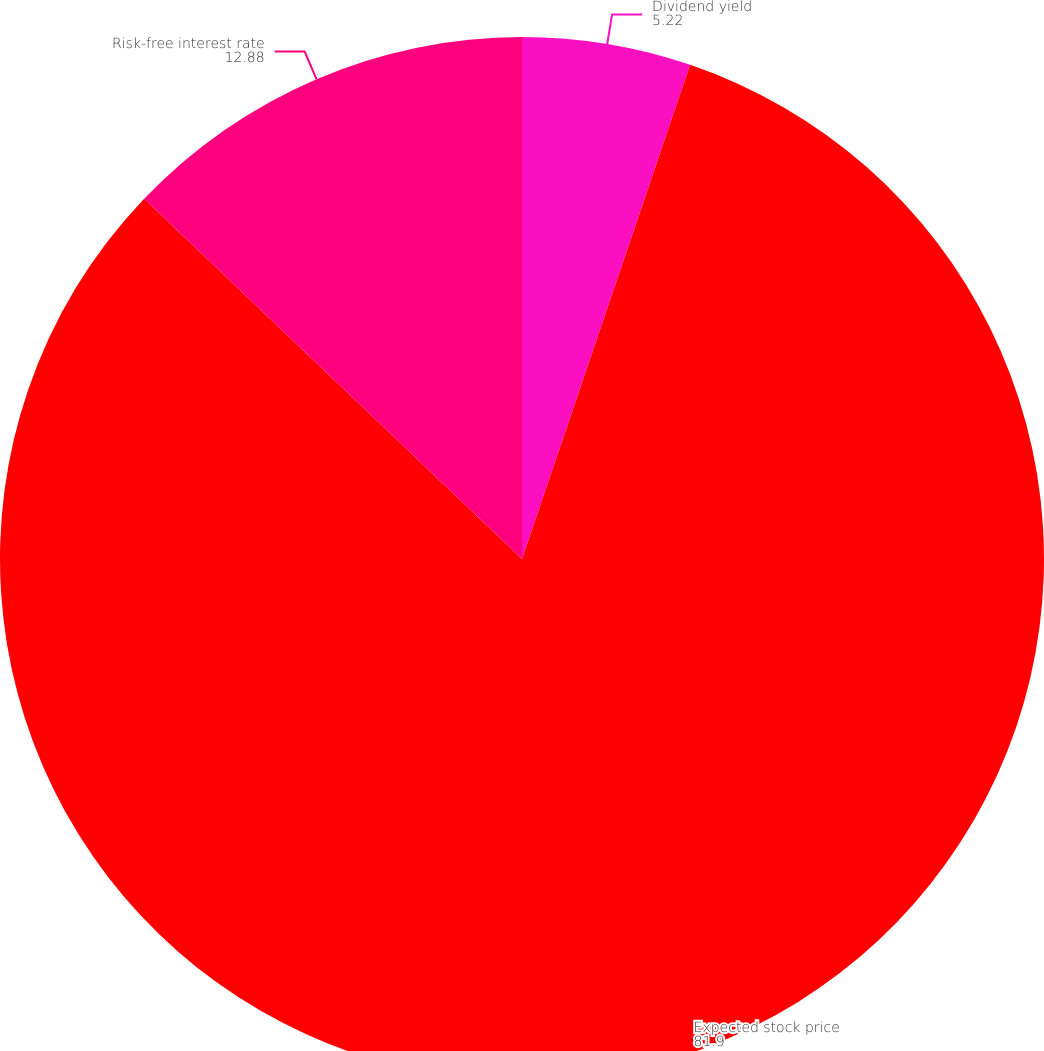<chart> <loc_0><loc_0><loc_500><loc_500><pie_chart><fcel>Dividend yield<fcel>Expected stock price<fcel>Risk-free interest rate<nl><fcel>5.22%<fcel>81.9%<fcel>12.88%<nl></chart> 